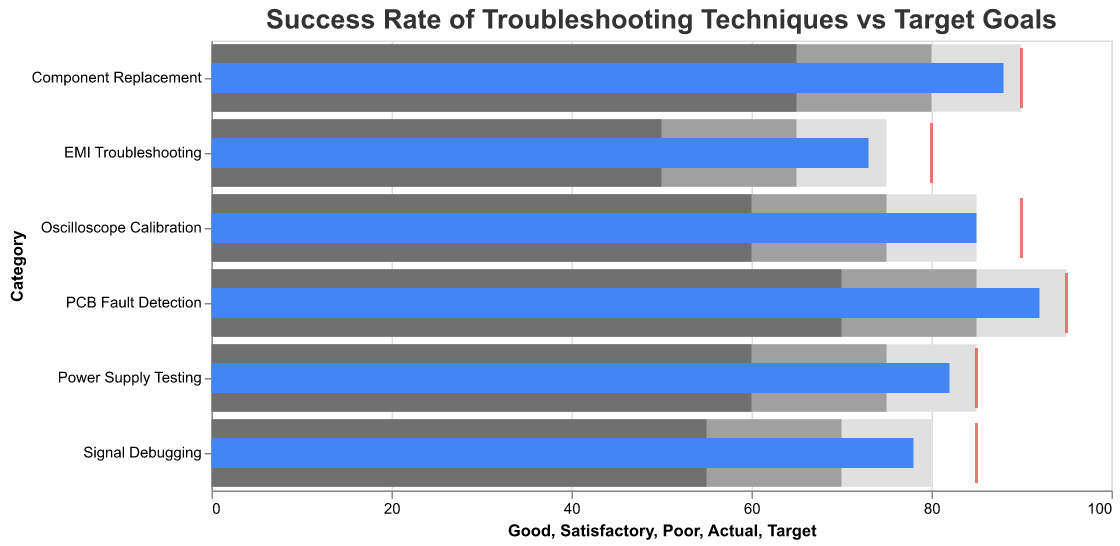What's the title of the chart? The title of the chart is located at the top of the figure and reads "Success Rate of Troubleshooting Techniques vs Target Goals."
Answer: Success Rate of Troubleshooting Techniques vs Target Goals What is the actual success rate for Oscilloscope Calibration? Look for the 'Actual' bar for Oscilloscope Calibration, which is colored blue and labeled "Oscilloscope Calibration."
Answer: 85 Which category has the highest target goal? All the target goals are represented by red ticks. Identify the one with the highest value. PCB Fault Detection has a target goal of 95, which is the highest among all categories.
Answer: PCB Fault Detection Is the actual success rate for EMI Troubleshooting above or below its target goal? Compare the blue bar representing the actual success rate for EMI Troubleshooting to the red tick representing its target goal. The actual success rate (73) is below the target goal (80).
Answer: Below How many categories have their actual success rate exceeding the "Good" threshold? Compare the blue bars to the "Good" threshold levels. Only Oscilloscope Calibration, PCB Fault Detection, and Component Replacement have their actual success rates meeting or exceeding their respective "Good" thresholds.
Answer: 3 What is the difference between the actual and target success rates for Signal Debugging? Subtract the actual success rate from the target success rate for Signal Debugging (85 - 78).
Answer: 7 For which category is the gap between the actual success rate and the "Poor" threshold the largest? Calculate the difference between the actual success rate and the "Poor" threshold for each category, then identify the largest one. Signal Debugging has the largest gap (78 - 55 = 23).
Answer: Signal Debugging What can be inferred about the success rate of Power Supply Testing compared to its target? By comparing the blue bar (actual success rate) with the red tick (target success rate) for Power Supply Testing, it is evident that the actual success rate (82) is slightly below the target (85).
Answer: Below Are there any categories where the actual success rate meets the target goal exactly? Look at the blue bars and red ticks to see if any are aligned at the same value. None of the categories have an actual success rate that meets the target goal exactly.
Answer: No 